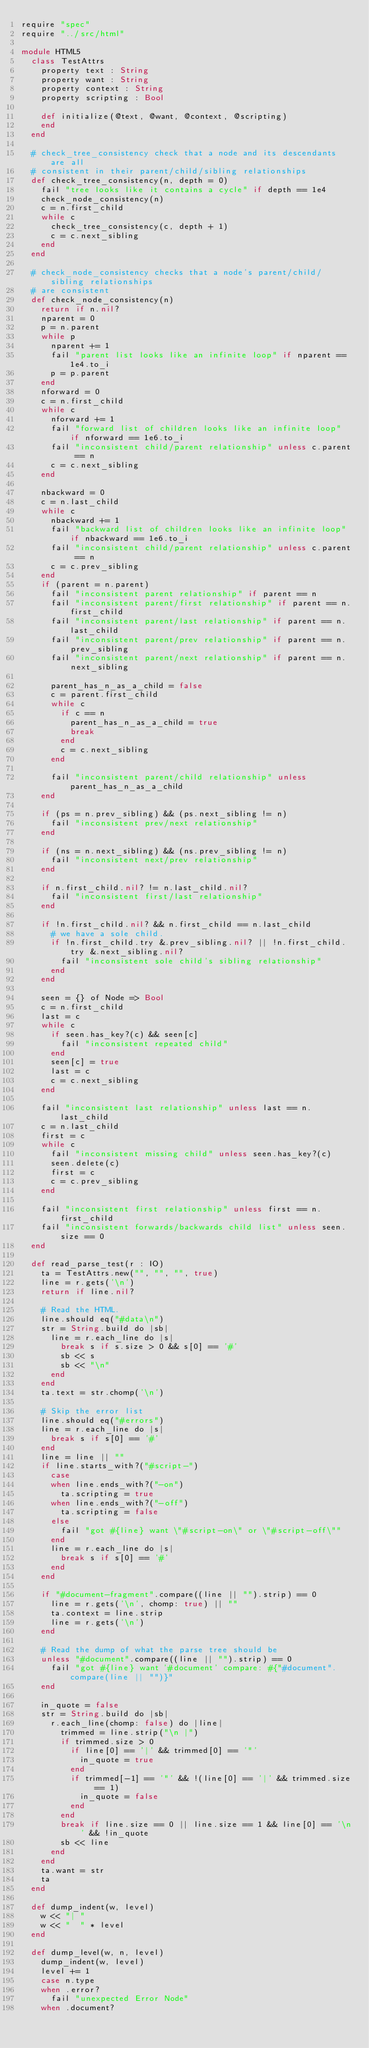Convert code to text. <code><loc_0><loc_0><loc_500><loc_500><_Crystal_>require "spec"
require "../src/html"

module HTML5
  class TestAttrs
    property text : String
    property want : String
    property context : String
    property scripting : Bool

    def initialize(@text, @want, @context, @scripting)
    end
  end

  # check_tree_consistency check that a node and its descendants are all
  # consistent in their parent/child/sibling relationships
  def check_tree_consistency(n, depth = 0)
    fail "tree looks like it contains a cycle" if depth == 1e4
    check_node_consistency(n)
    c = n.first_child
    while c
      check_tree_consistency(c, depth + 1)
      c = c.next_sibling
    end
  end

  # check_node_consistency checks that a node's parent/child/sibling relationships
  # are consistent
  def check_node_consistency(n)
    return if n.nil?
    nparent = 0
    p = n.parent
    while p
      nparent += 1
      fail "parent list looks like an infinite loop" if nparent == 1e4.to_i
      p = p.parent
    end
    nforward = 0
    c = n.first_child
    while c
      nforward += 1
      fail "forward list of children looks like an infinite loop" if nforward == 1e6.to_i
      fail "inconsistent child/parent relationship" unless c.parent == n
      c = c.next_sibling
    end

    nbackward = 0
    c = n.last_child
    while c
      nbackward += 1
      fail "backward list of children looks like an infinite loop" if nbackward == 1e6.to_i
      fail "inconsistent child/parent relationship" unless c.parent == n
      c = c.prev_sibling
    end
    if (parent = n.parent)
      fail "inconsistent parent relationship" if parent == n
      fail "inconsistent parent/first relationship" if parent == n.first_child
      fail "inconsistent parent/last relationship" if parent == n.last_child
      fail "inconsistent parent/prev relationship" if parent == n.prev_sibling
      fail "inconsistent parent/next relationship" if parent == n.next_sibling

      parent_has_n_as_a_child = false
      c = parent.first_child
      while c
        if c == n
          parent_has_n_as_a_child = true
          break
        end
        c = c.next_sibling
      end

      fail "inconsistent parent/child relationship" unless parent_has_n_as_a_child
    end

    if (ps = n.prev_sibling) && (ps.next_sibling != n)
      fail "inconsistent prev/next relationship"
    end

    if (ns = n.next_sibling) && (ns.prev_sibling != n)
      fail "inconsistent next/prev relationship"
    end

    if n.first_child.nil? != n.last_child.nil?
      fail "inconsistent first/last relationship"
    end

    if !n.first_child.nil? && n.first_child == n.last_child
      # we have a sole child.
      if !n.first_child.try &.prev_sibling.nil? || !n.first_child.try &.next_sibling.nil?
        fail "inconsistent sole child's sibling relationship"
      end
    end

    seen = {} of Node => Bool
    c = n.first_child
    last = c
    while c
      if seen.has_key?(c) && seen[c]
        fail "inconsistent repeated child"
      end
      seen[c] = true
      last = c
      c = c.next_sibling
    end

    fail "inconsistent last relationship" unless last == n.last_child
    c = n.last_child
    first = c
    while c
      fail "inconsistent missing child" unless seen.has_key?(c)
      seen.delete(c)
      first = c
      c = c.prev_sibling
    end

    fail "inconsistent first relationship" unless first == n.first_child
    fail "inconsistent forwards/backwards child list" unless seen.size == 0
  end

  def read_parse_test(r : IO)
    ta = TestAttrs.new("", "", "", true)
    line = r.gets('\n')
    return if line.nil?

    # Read the HTML.
    line.should eq("#data\n")
    str = String.build do |sb|
      line = r.each_line do |s|
        break s if s.size > 0 && s[0] == '#'
        sb << s
        sb << "\n"
      end
    end
    ta.text = str.chomp('\n')

    # Skip the error list
    line.should eq("#errors")
    line = r.each_line do |s|
      break s if s[0] == '#'
    end
    line = line || ""
    if line.starts_with?("#script-")
      case
      when line.ends_with?("-on")
        ta.scripting = true
      when line.ends_with?("-off")
        ta.scripting = false
      else
        fail "got #{line} want \"#script-on\" or \"#script-off\""
      end
      line = r.each_line do |s|
        break s if s[0] == '#'
      end
    end

    if "#document-fragment".compare((line || "").strip) == 0
      line = r.gets('\n', chomp: true) || ""
      ta.context = line.strip
      line = r.gets('\n')
    end

    # Read the dump of what the parse tree should be
    unless "#document".compare((line || "").strip) == 0
      fail "got #{line} want '#document' compare: #{"#document".compare(line || "")}"
    end

    in_quote = false
    str = String.build do |sb|
      r.each_line(chomp: false) do |line|
        trimmed = line.strip("\n |")
        if trimmed.size > 0
          if line[0] == '|' && trimmed[0] == '"'
            in_quote = true
          end
          if trimmed[-1] == '"' && !(line[0] == '|' && trimmed.size == 1)
            in_quote = false
          end
        end
        break if line.size == 0 || line.size == 1 && line[0] == '\n' && !in_quote
        sb << line
      end
    end
    ta.want = str
    ta
  end

  def dump_indent(w, level)
    w << "| "
    w << "  " * level
  end

  def dump_level(w, n, level)
    dump_indent(w, level)
    level += 1
    case n.type
    when .error?
      fail "unexpected Error Node"
    when .document?</code> 